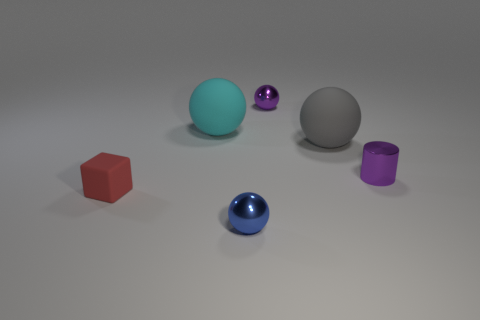Subtract all blue spheres. Subtract all blue cylinders. How many spheres are left? 3 Add 2 purple cylinders. How many objects exist? 8 Subtract all balls. How many objects are left? 2 Add 4 red things. How many red things are left? 5 Add 4 tiny purple metallic balls. How many tiny purple metallic balls exist? 5 Subtract 0 brown cylinders. How many objects are left? 6 Subtract all red objects. Subtract all tiny gray cylinders. How many objects are left? 5 